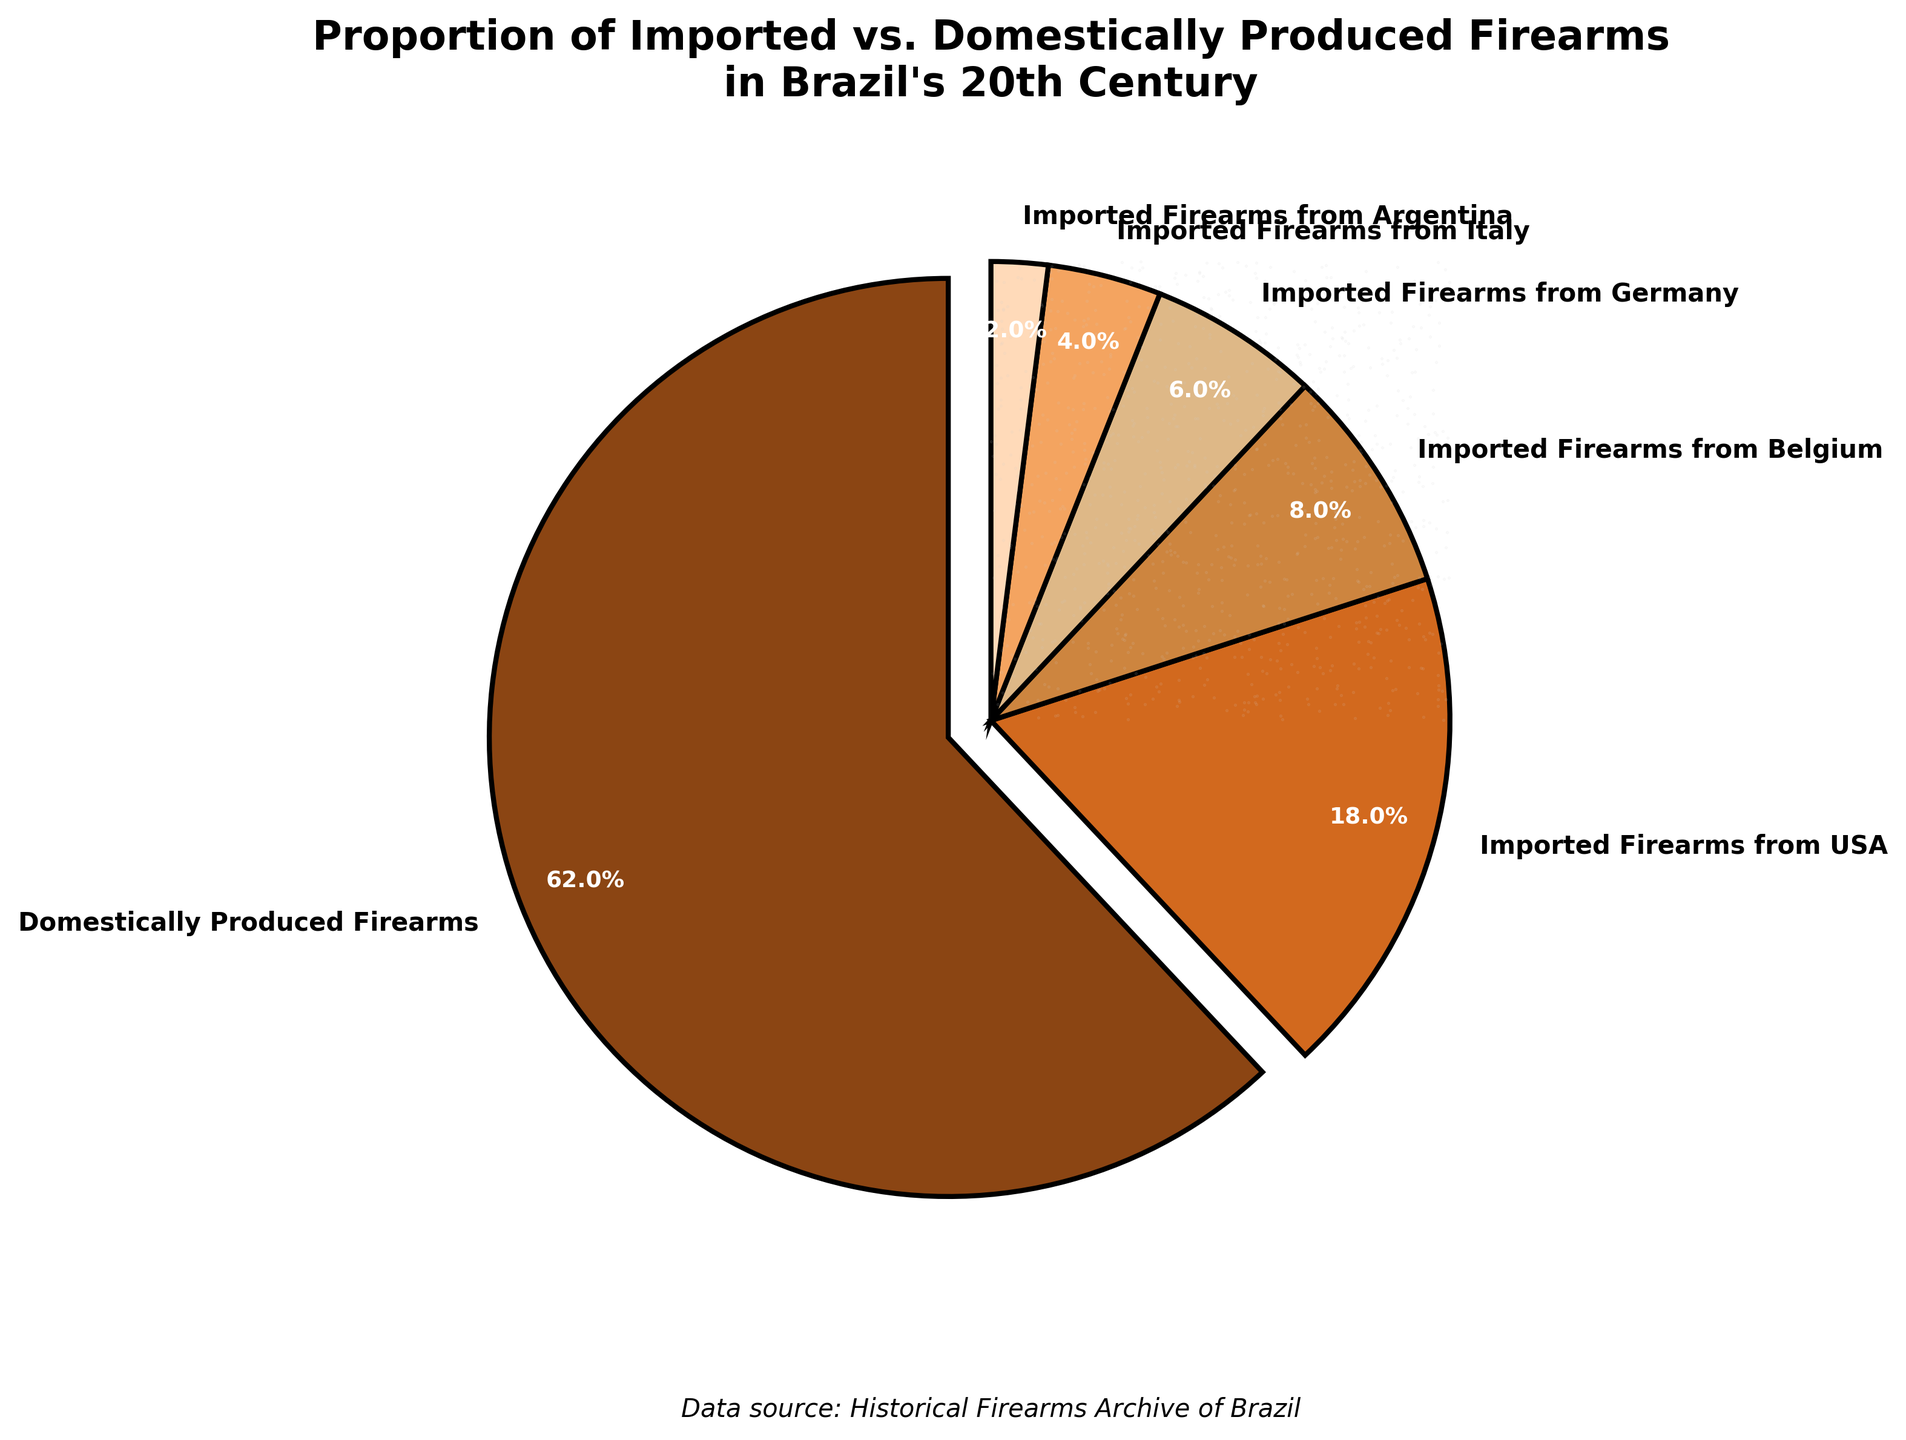What proportion of the firearms are domestically produced? The pie chart shows that domestically produced firearms account for 62% of the total firearms.
Answer: 62% Which country is the largest importer of firearms into Brazil in the 20th century? The chart indicates that the USA is the largest importer of firearms, contributing 18% of the firearms.
Answer: USA By how many percentage points does the proportion of domestically produced firearms exceed the sum of firearms imported from Belgium and Germany? The proportion of domestically produced firearms is 62%. Firearms imported from Belgium and Germany together account for 8% + 6% = 14%. Therefore, the difference is 62% - 14% = 48%.
Answer: 48% How does the proportion of firearms imported from Italy compare with those imported from Belgium? Firearms imported from Italy make up 4%, while those from Belgium account for 8%. Thus, the proportion from Italy is half that from Belgium.
Answer: Half What is the combined percentage of firearms imported from Argentina and Italy? The chart shows that Argentina accounts for 2% and Italy accounts for 4%. Their combined percentage is 2% + 4% = 6%.
Answer: 6% Which category has the smallest proportion of firearms, and what is that proportion? According to the chart, firearms imported from Argentina have the smallest proportion at 2%.
Answer: Firearms imported from Argentina, 2% What is the total percentage of firearms that are imported (from all listed countries combined)? The chart shows individual import percentages as: USA (18%), Belgium (8%), Germany (6%), Italy (4%), and Argentina (2%). Adding them gives 18% + 8% + 6% + 4% + 2% = 38%.
Answer: 38% In which direction does the largest wedge, representing domestically produced firearms, point? The largest wedge representing domestically produced firearms is oriented to the right, starting at the 90-degree mark and extending counter-clockwise.
Answer: To the right 